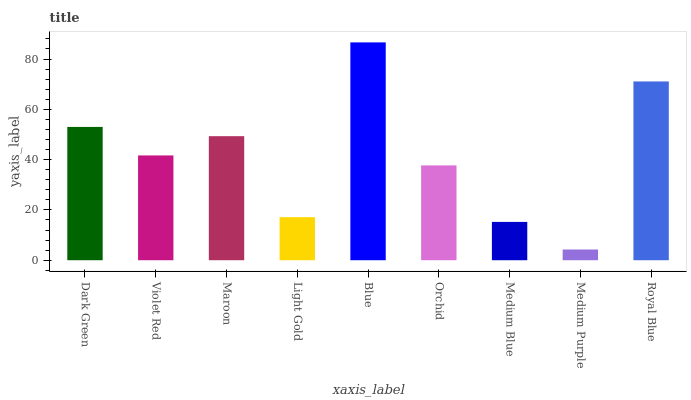Is Medium Purple the minimum?
Answer yes or no. Yes. Is Blue the maximum?
Answer yes or no. Yes. Is Violet Red the minimum?
Answer yes or no. No. Is Violet Red the maximum?
Answer yes or no. No. Is Dark Green greater than Violet Red?
Answer yes or no. Yes. Is Violet Red less than Dark Green?
Answer yes or no. Yes. Is Violet Red greater than Dark Green?
Answer yes or no. No. Is Dark Green less than Violet Red?
Answer yes or no. No. Is Violet Red the high median?
Answer yes or no. Yes. Is Violet Red the low median?
Answer yes or no. Yes. Is Medium Blue the high median?
Answer yes or no. No. Is Royal Blue the low median?
Answer yes or no. No. 